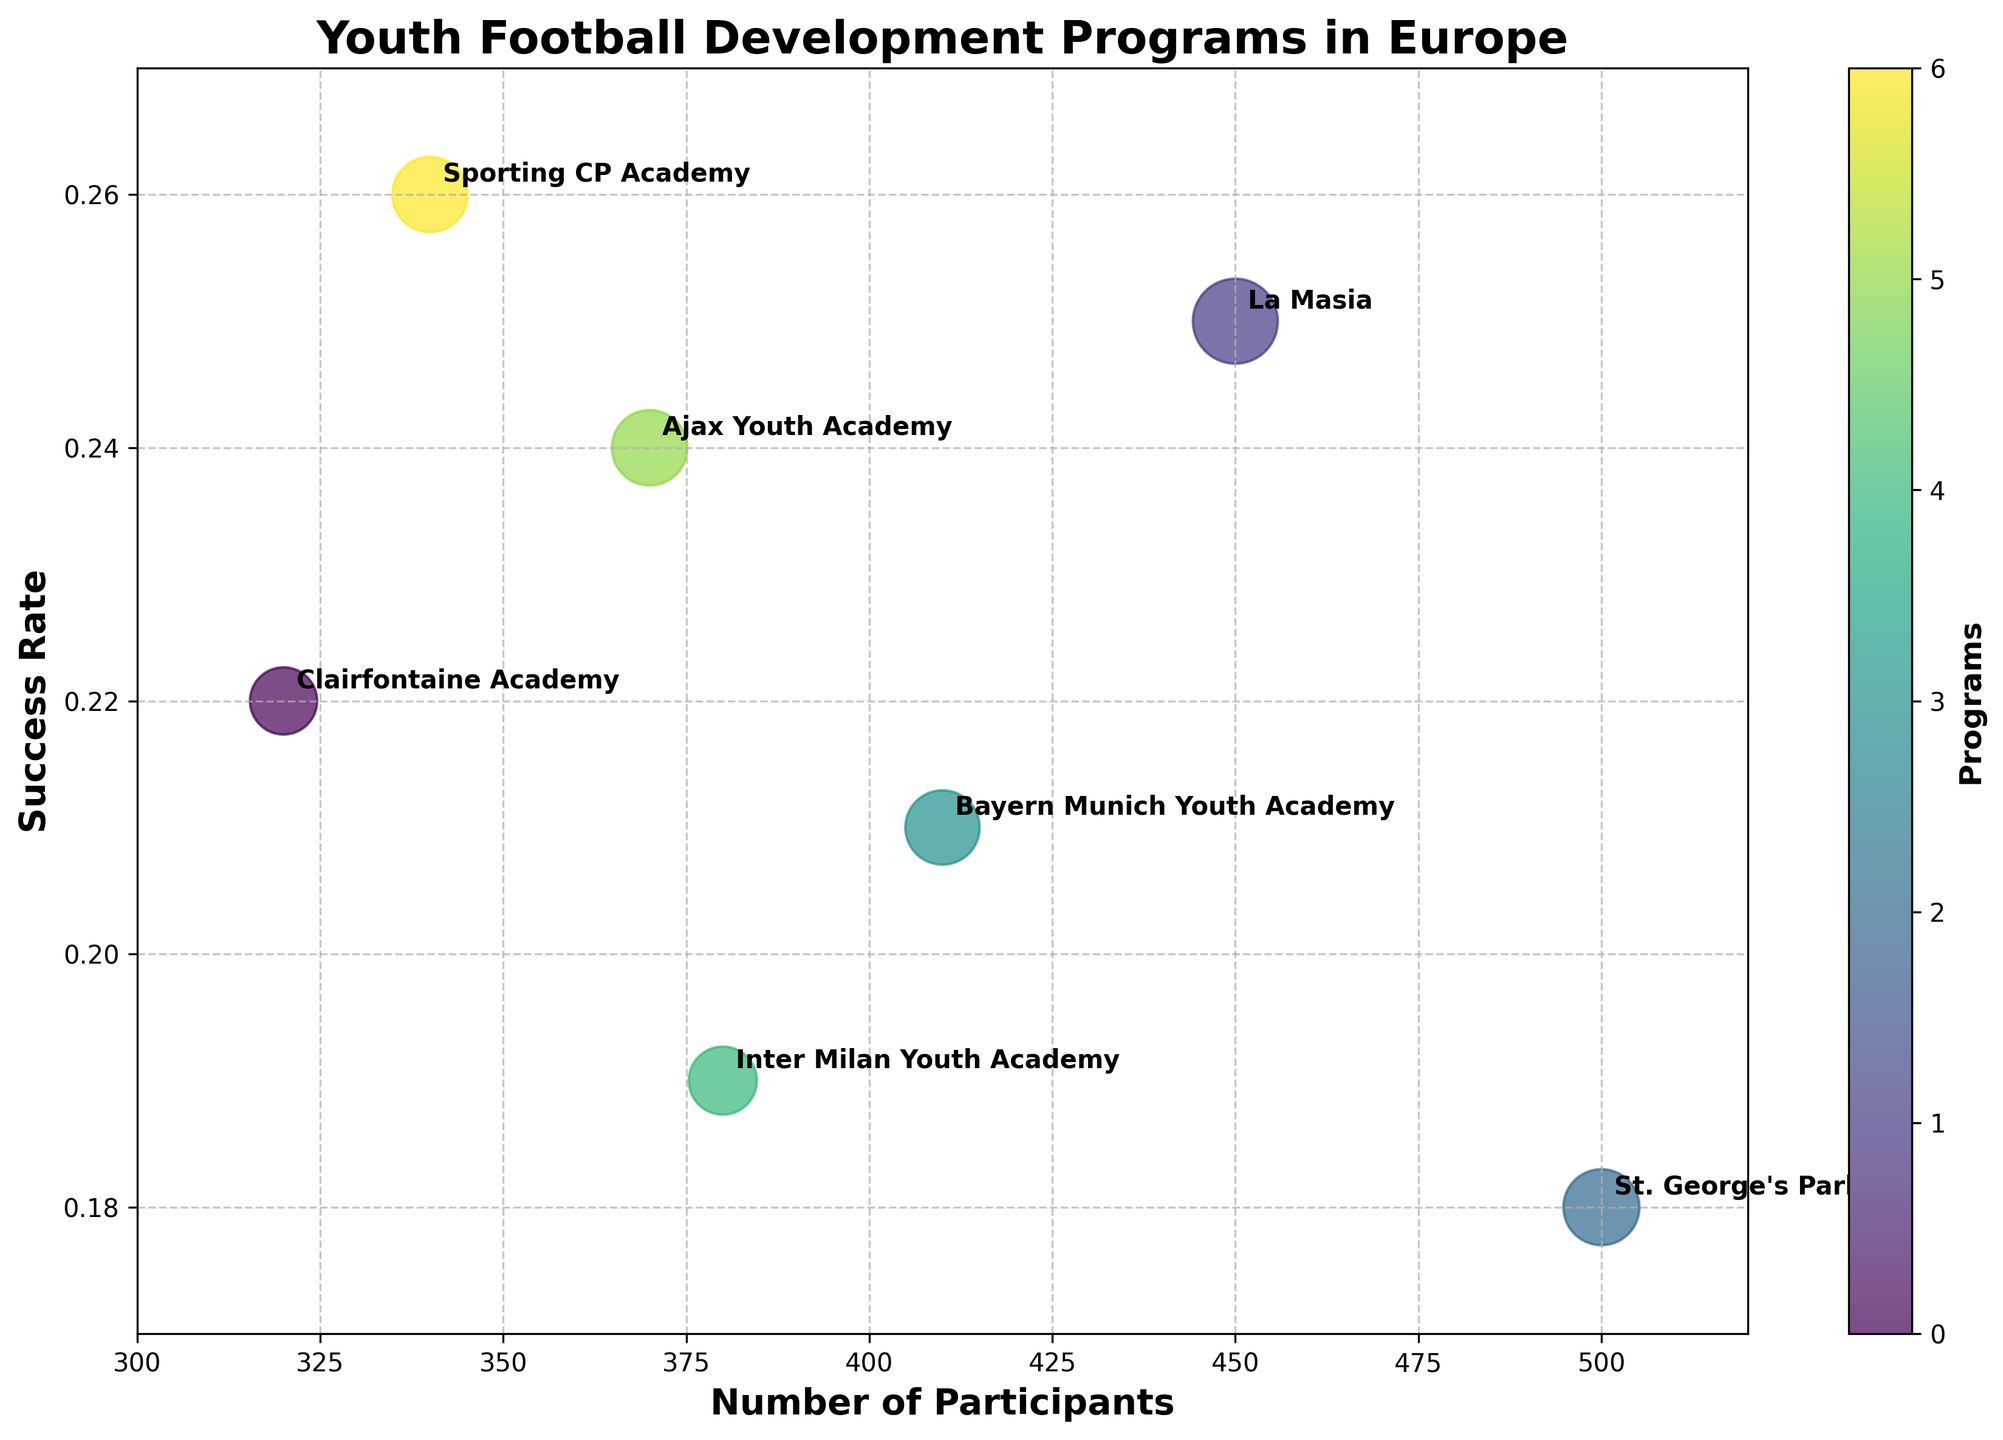What's the title of the figure? The title is displayed at the top of the figure and is typically the most prominent text.
Answer: Youth Football Development Programs in Europe What are the labels for the x-axis and y-axis? The x-axis and y-axis labels are positioned next to their respective axes, written in bold text.
Answer: Number of Participants, Success Rate Which program has the highest success rate? To find this, look at the y-axis values for each bubble and identify the one positioned highest on the y-axis.
Answer: Sporting CP Academy How many participants does La Masia have? Locate the La Masia bubble and refer to its position on the x-axis to determine the number of participants.
Answer: 450 What's the success rate for the St. George's Park program? Locate the St. George's Park bubble and check its position along the y-axis.
Answer: 0.18 Which program has the largest bubble? The size of the bubble is determined by the product of the number of participants and the success rate. Find the bubble with the greatest visual size.
Answer: St. George's Park Compare the number of participants between Bayern Munich Youth Academy and Clairfontaine Academy. Which one has more participants? Locate both bubbles on the x-axis and compare their positions to see which one is further right.
Answer: St. George's Park What's the average success rate across all the programs shown? Sum the success rates of all the programs and divide by the number of programs: (0.22 + 0.25 + 0.18 + 0.21 + 0.19 + 0.24 + 0.26) / 7.
Answer: 0.22 Which programs have a success rate higher than 0.2? Identify bubbles positioned above the 0.2 mark on the y-axis.
Answer: Clairfontaine Academy, La Masia, Bayern Munich Youth Academy, Ajax Youth Academy, Sporting CP Academy How does the success rate of Ajax Youth Academy compare to Inter Milan Youth Academy? Locate both bubbles and compare their positions on the y-axis to determine which is higher.
Answer: Higher 